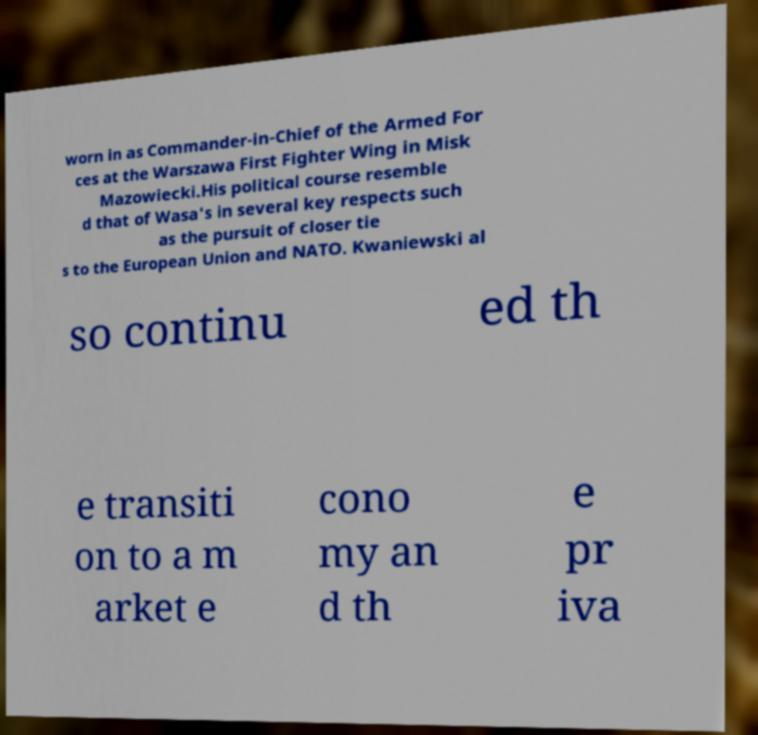I need the written content from this picture converted into text. Can you do that? worn in as Commander-in-Chief of the Armed For ces at the Warszawa First Fighter Wing in Misk Mazowiecki.His political course resemble d that of Wasa's in several key respects such as the pursuit of closer tie s to the European Union and NATO. Kwaniewski al so continu ed th e transiti on to a m arket e cono my an d th e pr iva 